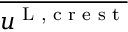Convert formula to latex. <formula><loc_0><loc_0><loc_500><loc_500>\overline { { u ^ { L , c r e s t } } }</formula> 